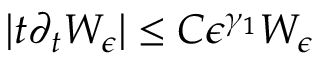<formula> <loc_0><loc_0><loc_500><loc_500>| t \partial _ { t } W _ { \epsilon } | \leq C \epsilon ^ { \gamma _ { 1 } } W _ { \epsilon }</formula> 